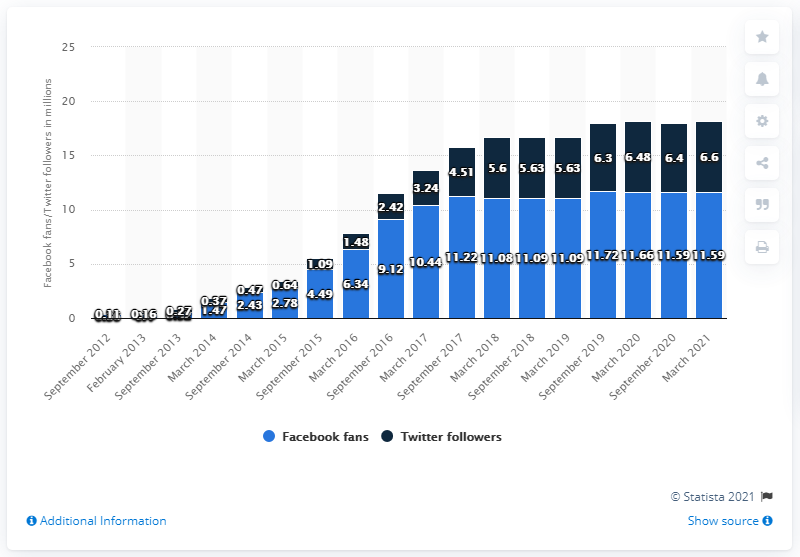Point out several critical features in this image. In March 2021, the Golden State Warriors basketball team had 11,590 fans on their Facebook page. 